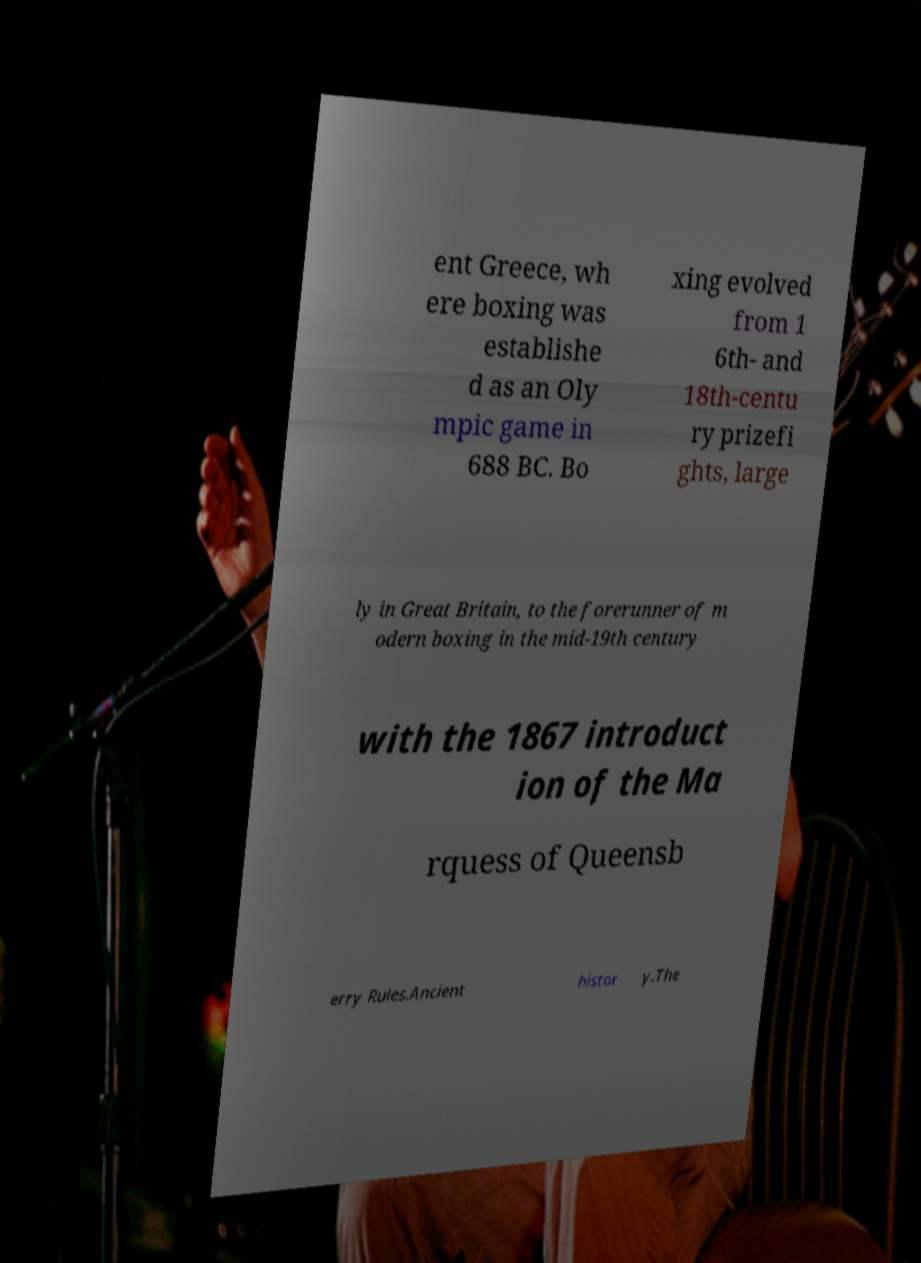Could you assist in decoding the text presented in this image and type it out clearly? ent Greece, wh ere boxing was establishe d as an Oly mpic game in 688 BC. Bo xing evolved from 1 6th- and 18th-centu ry prizefi ghts, large ly in Great Britain, to the forerunner of m odern boxing in the mid-19th century with the 1867 introduct ion of the Ma rquess of Queensb erry Rules.Ancient histor y.The 